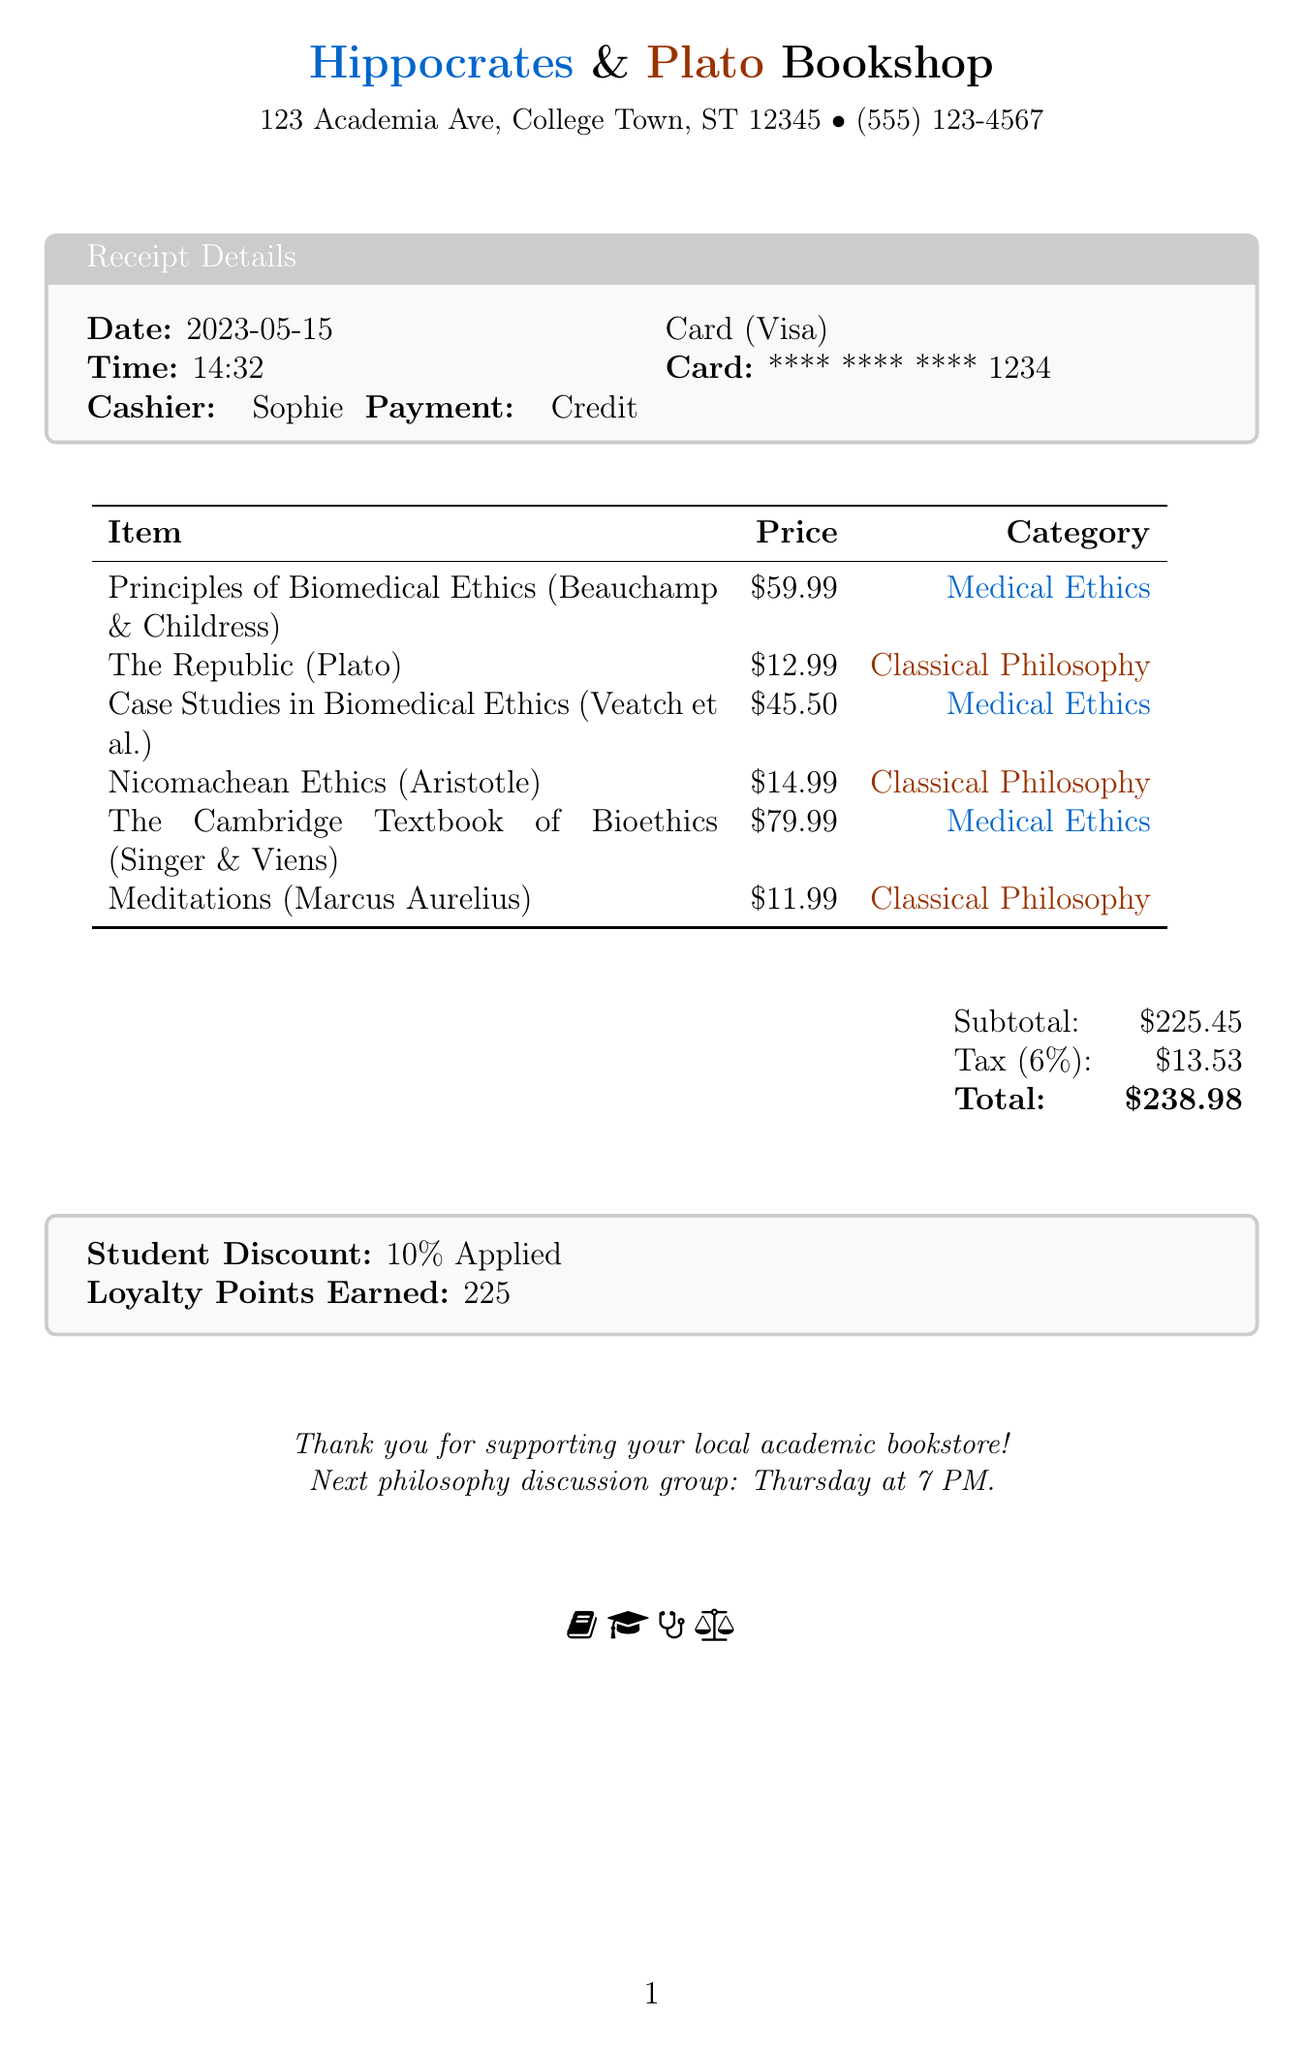What is the name of the bookstore? The receipt indicates the name of the bookstore at the top: "Hippocrates & Plato Bookshop."
Answer: Hippocrates & Plato Bookshop What date was the purchase made? The date of the transaction is specified in the receipt details section.
Answer: 2023-05-15 Who was the cashier during the transaction? The name of the cashier is stated in the receipt details.
Answer: Sophie What is the total amount spent? The total amount is provided at the bottom of the receipt.
Answer: $238.98 How much tax was applied to the purchase? The tax amount is specified in the subtotal section of the receipt.
Answer: $13.53 What is the student discount percentage? The receipt mentions the applied student discount in the designated box.
Answer: 10% What type of payment was used? The method of payment is noted in the receipt details section.
Answer: Credit Card Which classical philosophy text was purchased for the lowest price? The prices and titles of the classical philosophy texts can be compared to identify the lowest.
Answer: Meditations How many loyalty points were earned from this purchase? The loyalty points earned are listed in the footer section of the receipt.
Answer: 225 